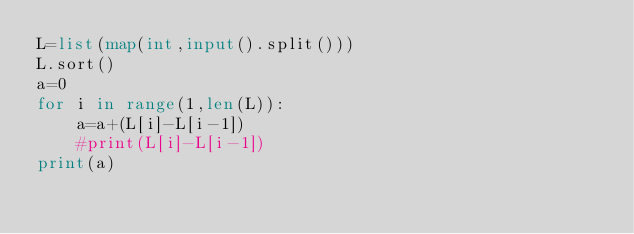<code> <loc_0><loc_0><loc_500><loc_500><_Python_>L=list(map(int,input().split()))
L.sort()
a=0
for i in range(1,len(L)):
    a=a+(L[i]-L[i-1])
    #print(L[i]-L[i-1])
print(a)</code> 